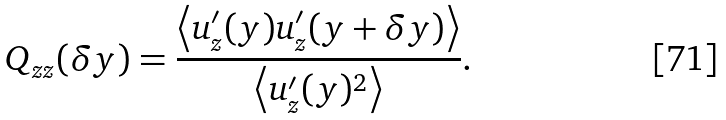Convert formula to latex. <formula><loc_0><loc_0><loc_500><loc_500>Q _ { z z } ( \delta y ) = \frac { \left < u ^ { \prime } _ { z } ( y ) u ^ { \prime } _ { z } ( y + \delta y ) \right > } { \left < u ^ { \prime } _ { z } ( y ) ^ { 2 } \right > } .</formula> 